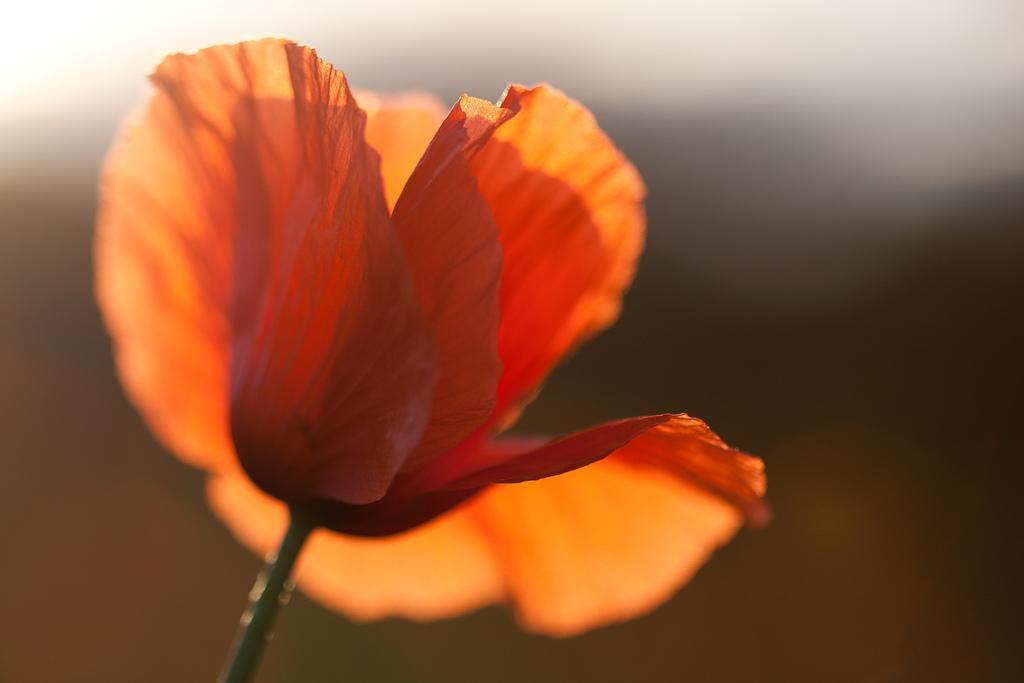In one or two sentences, can you explain what this image depicts? In this image we can see a flower which is in saffron color. 